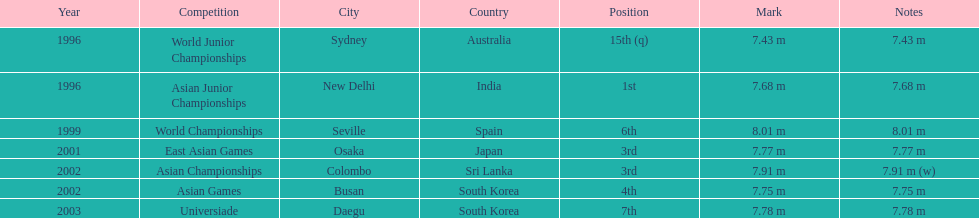In what year was the position of 3rd first achieved? 2001. 